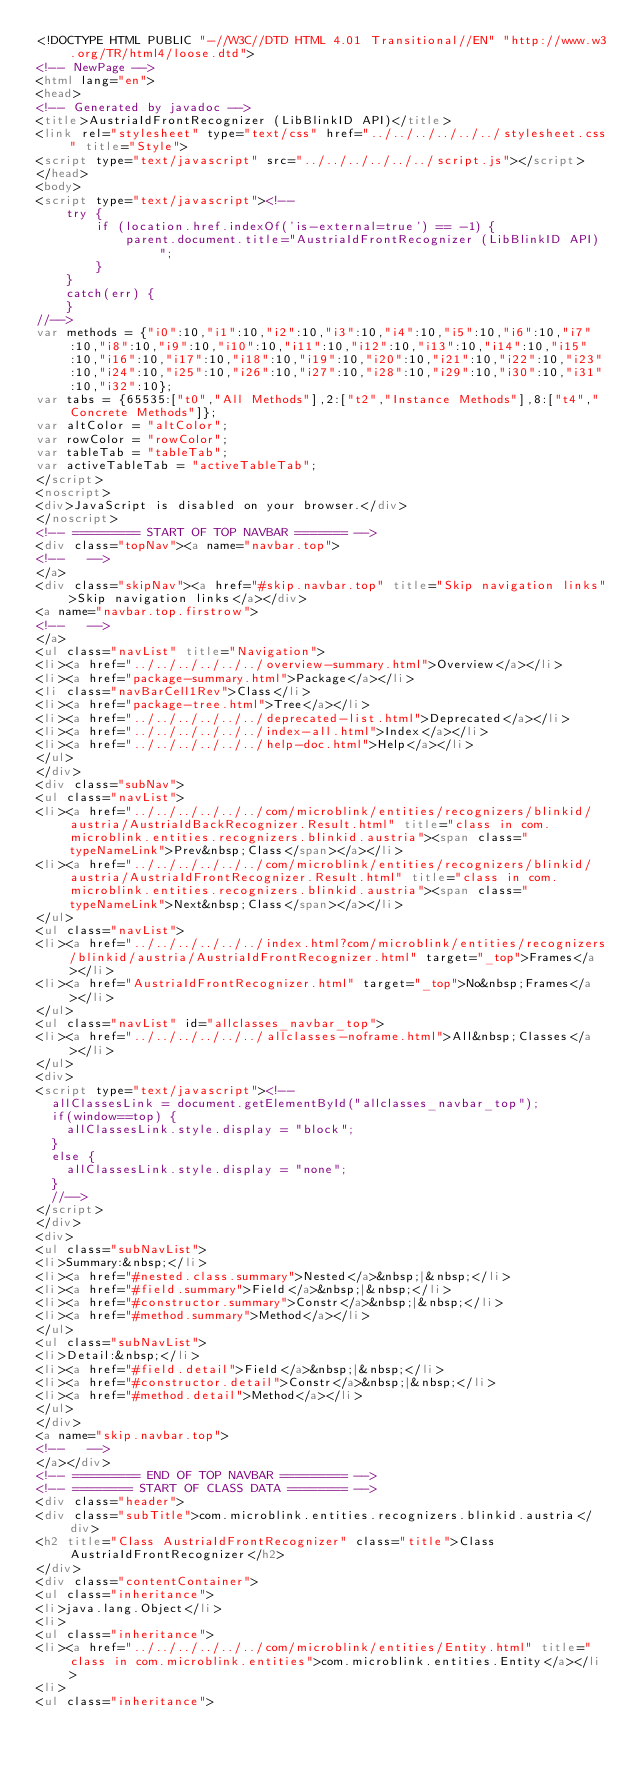Convert code to text. <code><loc_0><loc_0><loc_500><loc_500><_HTML_><!DOCTYPE HTML PUBLIC "-//W3C//DTD HTML 4.01 Transitional//EN" "http://www.w3.org/TR/html4/loose.dtd">
<!-- NewPage -->
<html lang="en">
<head>
<!-- Generated by javadoc -->
<title>AustriaIdFrontRecognizer (LibBlinkID API)</title>
<link rel="stylesheet" type="text/css" href="../../../../../../stylesheet.css" title="Style">
<script type="text/javascript" src="../../../../../../script.js"></script>
</head>
<body>
<script type="text/javascript"><!--
    try {
        if (location.href.indexOf('is-external=true') == -1) {
            parent.document.title="AustriaIdFrontRecognizer (LibBlinkID API)";
        }
    }
    catch(err) {
    }
//-->
var methods = {"i0":10,"i1":10,"i2":10,"i3":10,"i4":10,"i5":10,"i6":10,"i7":10,"i8":10,"i9":10,"i10":10,"i11":10,"i12":10,"i13":10,"i14":10,"i15":10,"i16":10,"i17":10,"i18":10,"i19":10,"i20":10,"i21":10,"i22":10,"i23":10,"i24":10,"i25":10,"i26":10,"i27":10,"i28":10,"i29":10,"i30":10,"i31":10,"i32":10};
var tabs = {65535:["t0","All Methods"],2:["t2","Instance Methods"],8:["t4","Concrete Methods"]};
var altColor = "altColor";
var rowColor = "rowColor";
var tableTab = "tableTab";
var activeTableTab = "activeTableTab";
</script>
<noscript>
<div>JavaScript is disabled on your browser.</div>
</noscript>
<!-- ========= START OF TOP NAVBAR ======= -->
<div class="topNav"><a name="navbar.top">
<!--   -->
</a>
<div class="skipNav"><a href="#skip.navbar.top" title="Skip navigation links">Skip navigation links</a></div>
<a name="navbar.top.firstrow">
<!--   -->
</a>
<ul class="navList" title="Navigation">
<li><a href="../../../../../../overview-summary.html">Overview</a></li>
<li><a href="package-summary.html">Package</a></li>
<li class="navBarCell1Rev">Class</li>
<li><a href="package-tree.html">Tree</a></li>
<li><a href="../../../../../../deprecated-list.html">Deprecated</a></li>
<li><a href="../../../../../../index-all.html">Index</a></li>
<li><a href="../../../../../../help-doc.html">Help</a></li>
</ul>
</div>
<div class="subNav">
<ul class="navList">
<li><a href="../../../../../../com/microblink/entities/recognizers/blinkid/austria/AustriaIdBackRecognizer.Result.html" title="class in com.microblink.entities.recognizers.blinkid.austria"><span class="typeNameLink">Prev&nbsp;Class</span></a></li>
<li><a href="../../../../../../com/microblink/entities/recognizers/blinkid/austria/AustriaIdFrontRecognizer.Result.html" title="class in com.microblink.entities.recognizers.blinkid.austria"><span class="typeNameLink">Next&nbsp;Class</span></a></li>
</ul>
<ul class="navList">
<li><a href="../../../../../../index.html?com/microblink/entities/recognizers/blinkid/austria/AustriaIdFrontRecognizer.html" target="_top">Frames</a></li>
<li><a href="AustriaIdFrontRecognizer.html" target="_top">No&nbsp;Frames</a></li>
</ul>
<ul class="navList" id="allclasses_navbar_top">
<li><a href="../../../../../../allclasses-noframe.html">All&nbsp;Classes</a></li>
</ul>
<div>
<script type="text/javascript"><!--
  allClassesLink = document.getElementById("allclasses_navbar_top");
  if(window==top) {
    allClassesLink.style.display = "block";
  }
  else {
    allClassesLink.style.display = "none";
  }
  //-->
</script>
</div>
<div>
<ul class="subNavList">
<li>Summary:&nbsp;</li>
<li><a href="#nested.class.summary">Nested</a>&nbsp;|&nbsp;</li>
<li><a href="#field.summary">Field</a>&nbsp;|&nbsp;</li>
<li><a href="#constructor.summary">Constr</a>&nbsp;|&nbsp;</li>
<li><a href="#method.summary">Method</a></li>
</ul>
<ul class="subNavList">
<li>Detail:&nbsp;</li>
<li><a href="#field.detail">Field</a>&nbsp;|&nbsp;</li>
<li><a href="#constructor.detail">Constr</a>&nbsp;|&nbsp;</li>
<li><a href="#method.detail">Method</a></li>
</ul>
</div>
<a name="skip.navbar.top">
<!--   -->
</a></div>
<!-- ========= END OF TOP NAVBAR ========= -->
<!-- ======== START OF CLASS DATA ======== -->
<div class="header">
<div class="subTitle">com.microblink.entities.recognizers.blinkid.austria</div>
<h2 title="Class AustriaIdFrontRecognizer" class="title">Class AustriaIdFrontRecognizer</h2>
</div>
<div class="contentContainer">
<ul class="inheritance">
<li>java.lang.Object</li>
<li>
<ul class="inheritance">
<li><a href="../../../../../../com/microblink/entities/Entity.html" title="class in com.microblink.entities">com.microblink.entities.Entity</a></li>
<li>
<ul class="inheritance"></code> 